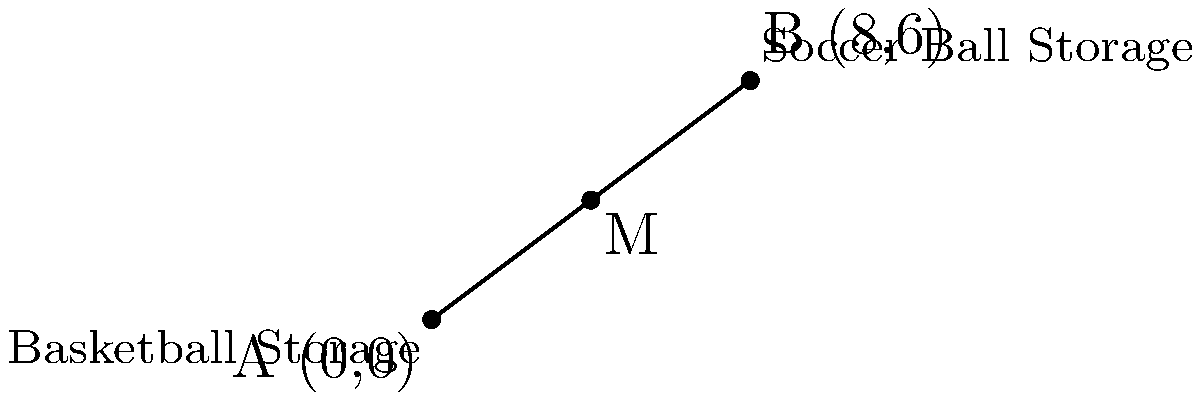In the school gym, there are two equipment storage locations: one for basketballs at point A (0,0) and another for soccer balls at point B (8,6). To make it easier for you to access both types of equipment, the coach wants to place a new storage rack at the midpoint between these two locations. What are the coordinates of this new storage rack? To find the midpoint of a line segment, we can use the midpoint formula:

$$ M_x = \frac{x_1 + x_2}{2}, \quad M_y = \frac{y_1 + y_2}{2} $$

Where $(x_1, y_1)$ are the coordinates of point A, and $(x_2, y_2)$ are the coordinates of point B.

Step 1: Identify the coordinates
Point A (Basketball Storage): $(0, 0)$
Point B (Soccer Ball Storage): $(8, 6)$

Step 2: Apply the midpoint formula for x-coordinate
$$ M_x = \frac{0 + 8}{2} = \frac{8}{2} = 4 $$

Step 3: Apply the midpoint formula for y-coordinate
$$ M_y = \frac{0 + 6}{2} = \frac{6}{2} = 3 $$

Step 4: Combine the results
The midpoint M has coordinates $(4, 3)$.

Therefore, the new storage rack should be placed at the point (4, 3) in the coordinate system of the gym.
Answer: (4, 3) 